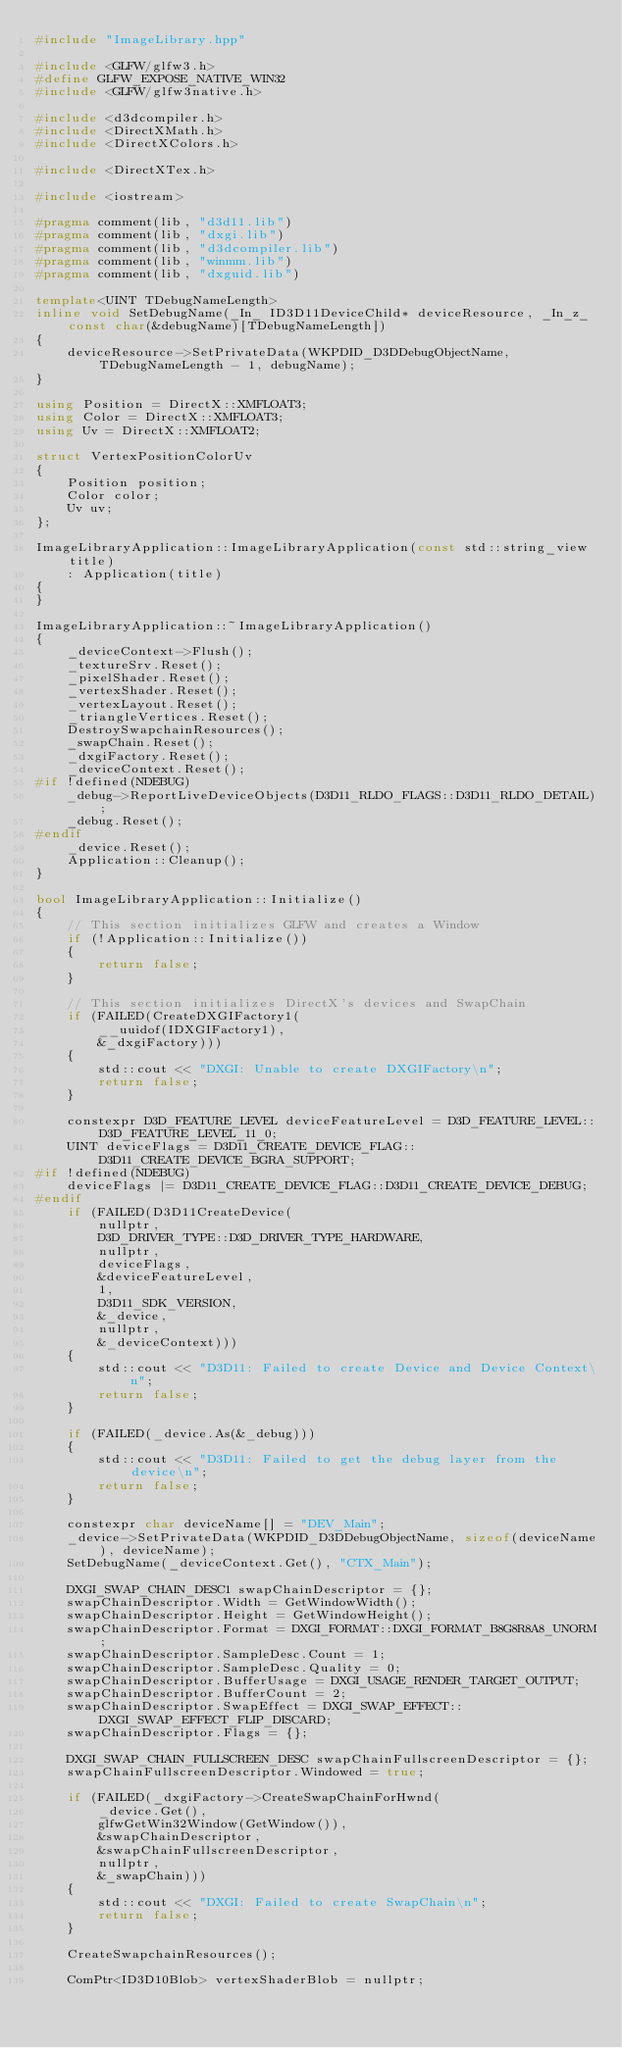<code> <loc_0><loc_0><loc_500><loc_500><_C++_>#include "ImageLibrary.hpp"

#include <GLFW/glfw3.h>
#define GLFW_EXPOSE_NATIVE_WIN32
#include <GLFW/glfw3native.h>

#include <d3dcompiler.h>
#include <DirectXMath.h>
#include <DirectXColors.h>

#include <DirectXTex.h>

#include <iostream>

#pragma comment(lib, "d3d11.lib")
#pragma comment(lib, "dxgi.lib")
#pragma comment(lib, "d3dcompiler.lib")
#pragma comment(lib, "winmm.lib")
#pragma comment(lib, "dxguid.lib")

template<UINT TDebugNameLength>
inline void SetDebugName(_In_ ID3D11DeviceChild* deviceResource, _In_z_ const char(&debugName)[TDebugNameLength])
{
    deviceResource->SetPrivateData(WKPDID_D3DDebugObjectName, TDebugNameLength - 1, debugName);
}

using Position = DirectX::XMFLOAT3;
using Color = DirectX::XMFLOAT3;
using Uv = DirectX::XMFLOAT2;

struct VertexPositionColorUv
{
    Position position;
    Color color;
    Uv uv;
};

ImageLibraryApplication::ImageLibraryApplication(const std::string_view title)
    : Application(title)
{
}

ImageLibraryApplication::~ImageLibraryApplication()
{
    _deviceContext->Flush();
    _textureSrv.Reset();
    _pixelShader.Reset();
    _vertexShader.Reset();
    _vertexLayout.Reset();
    _triangleVertices.Reset();
    DestroySwapchainResources();
    _swapChain.Reset();
    _dxgiFactory.Reset();
    _deviceContext.Reset();
#if !defined(NDEBUG)
    _debug->ReportLiveDeviceObjects(D3D11_RLDO_FLAGS::D3D11_RLDO_DETAIL);
    _debug.Reset();
#endif
    _device.Reset();
    Application::Cleanup();
}

bool ImageLibraryApplication::Initialize()
{
    // This section initializes GLFW and creates a Window
    if (!Application::Initialize())
    {
        return false;
    }

    // This section initializes DirectX's devices and SwapChain
    if (FAILED(CreateDXGIFactory1(
        __uuidof(IDXGIFactory1),
        &_dxgiFactory)))
    {
        std::cout << "DXGI: Unable to create DXGIFactory\n";
        return false;
    }

    constexpr D3D_FEATURE_LEVEL deviceFeatureLevel = D3D_FEATURE_LEVEL::D3D_FEATURE_LEVEL_11_0;
    UINT deviceFlags = D3D11_CREATE_DEVICE_FLAG::D3D11_CREATE_DEVICE_BGRA_SUPPORT;
#if !defined(NDEBUG)
    deviceFlags |= D3D11_CREATE_DEVICE_FLAG::D3D11_CREATE_DEVICE_DEBUG;
#endif
    if (FAILED(D3D11CreateDevice(
        nullptr,
        D3D_DRIVER_TYPE::D3D_DRIVER_TYPE_HARDWARE,
        nullptr,
        deviceFlags,
        &deviceFeatureLevel,
        1,
        D3D11_SDK_VERSION,
        &_device,
        nullptr,
        &_deviceContext)))
    {
        std::cout << "D3D11: Failed to create Device and Device Context\n";
        return false;
    }

    if (FAILED(_device.As(&_debug)))
    {
        std::cout << "D3D11: Failed to get the debug layer from the device\n";
        return false;
    }

    constexpr char deviceName[] = "DEV_Main";
    _device->SetPrivateData(WKPDID_D3DDebugObjectName, sizeof(deviceName), deviceName);
    SetDebugName(_deviceContext.Get(), "CTX_Main");

    DXGI_SWAP_CHAIN_DESC1 swapChainDescriptor = {};
    swapChainDescriptor.Width = GetWindowWidth();
    swapChainDescriptor.Height = GetWindowHeight();
    swapChainDescriptor.Format = DXGI_FORMAT::DXGI_FORMAT_B8G8R8A8_UNORM;
    swapChainDescriptor.SampleDesc.Count = 1;
    swapChainDescriptor.SampleDesc.Quality = 0;
    swapChainDescriptor.BufferUsage = DXGI_USAGE_RENDER_TARGET_OUTPUT;
    swapChainDescriptor.BufferCount = 2;
    swapChainDescriptor.SwapEffect = DXGI_SWAP_EFFECT::DXGI_SWAP_EFFECT_FLIP_DISCARD;
    swapChainDescriptor.Flags = {};

    DXGI_SWAP_CHAIN_FULLSCREEN_DESC swapChainFullscreenDescriptor = {};
    swapChainFullscreenDescriptor.Windowed = true;

    if (FAILED(_dxgiFactory->CreateSwapChainForHwnd(
        _device.Get(),
        glfwGetWin32Window(GetWindow()),
        &swapChainDescriptor,
        &swapChainFullscreenDescriptor,
        nullptr,
        &_swapChain)))
    {
        std::cout << "DXGI: Failed to create SwapChain\n";
        return false;
    }

    CreateSwapchainResources();

    ComPtr<ID3D10Blob> vertexShaderBlob = nullptr;</code> 